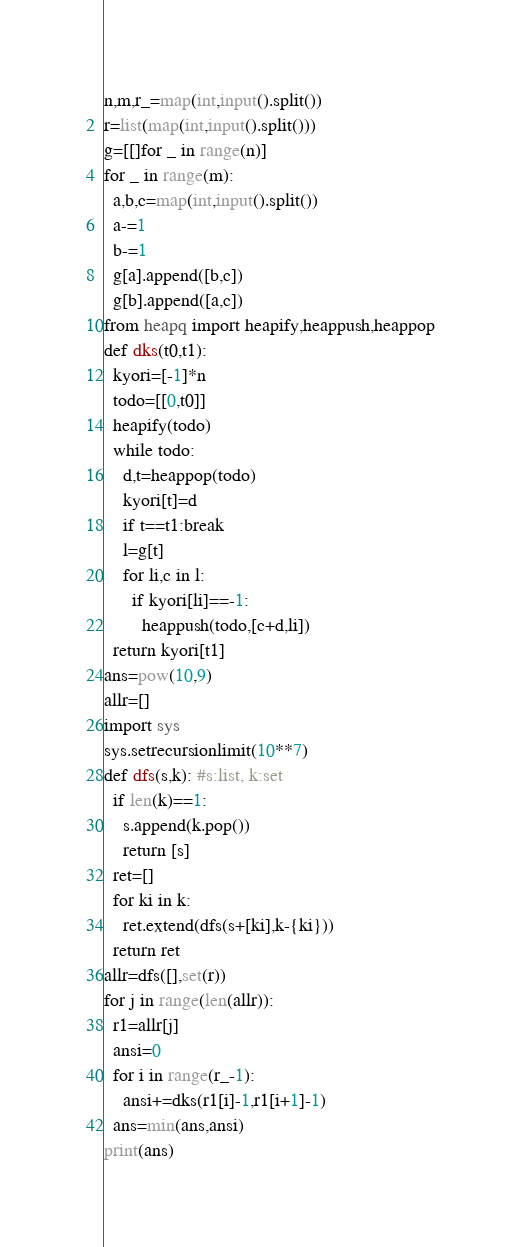<code> <loc_0><loc_0><loc_500><loc_500><_Python_>n,m,r_=map(int,input().split())
r=list(map(int,input().split()))
g=[[]for _ in range(n)]
for _ in range(m):
  a,b,c=map(int,input().split())
  a-=1
  b-=1
  g[a].append([b,c])
  g[b].append([a,c])
from heapq import heapify,heappush,heappop
def dks(t0,t1):
  kyori=[-1]*n
  todo=[[0,t0]]
  heapify(todo)
  while todo:
    d,t=heappop(todo)
    kyori[t]=d
    if t==t1:break
    l=g[t]
    for li,c in l:
      if kyori[li]==-1:
        heappush(todo,[c+d,li])
  return kyori[t1]
ans=pow(10,9)
allr=[]
import sys
sys.setrecursionlimit(10**7)
def dfs(s,k): #s:list, k:set
  if len(k)==1:
    s.append(k.pop())
    return [s]
  ret=[]
  for ki in k:
    ret.extend(dfs(s+[ki],k-{ki}))
  return ret
allr=dfs([],set(r))
for j in range(len(allr)):
  r1=allr[j]
  ansi=0
  for i in range(r_-1):
    ansi+=dks(r1[i]-1,r1[i+1]-1)
  ans=min(ans,ansi)
print(ans)
</code> 